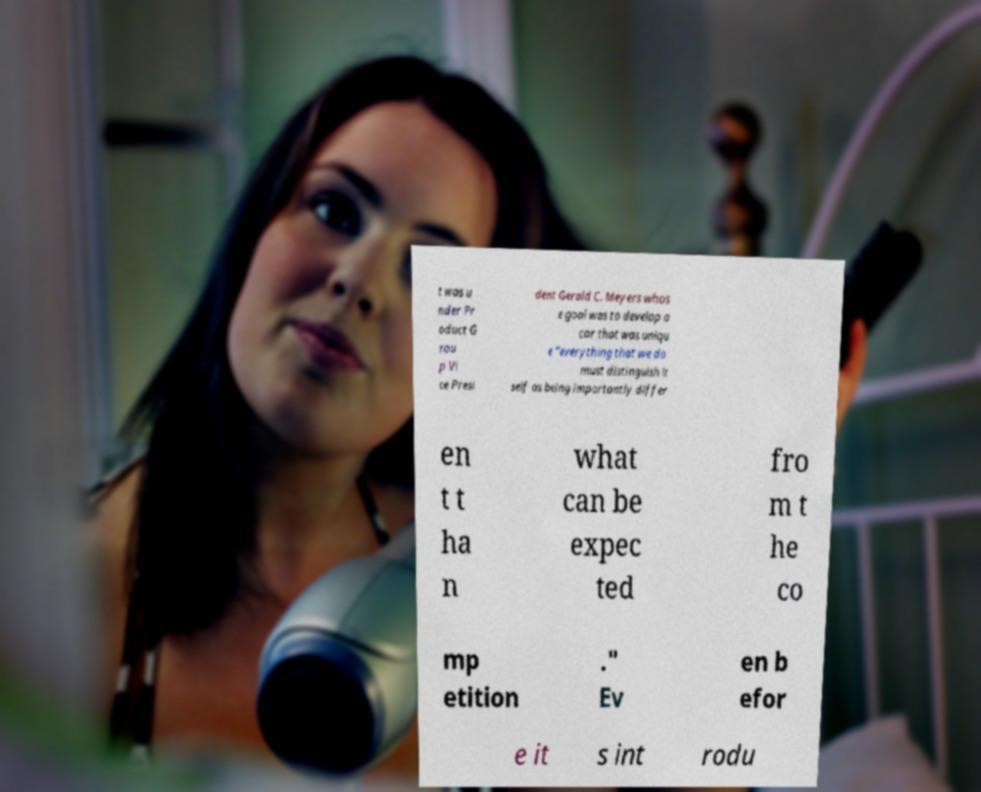Please identify and transcribe the text found in this image. t was u nder Pr oduct G rou p Vi ce Presi dent Gerald C. Meyers whos e goal was to develop a car that was uniqu e "everything that we do must distinguish it self as being importantly differ en t t ha n what can be expec ted fro m t he co mp etition ." Ev en b efor e it s int rodu 